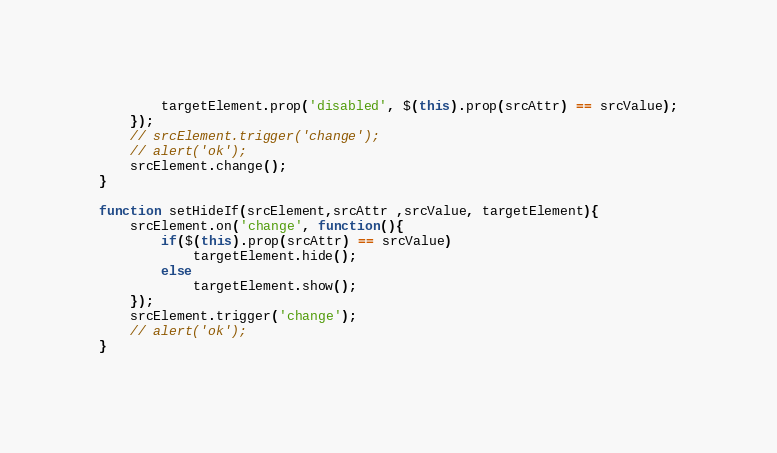<code> <loc_0><loc_0><loc_500><loc_500><_JavaScript_>        targetElement.prop('disabled', $(this).prop(srcAttr) == srcValue);
    });
    // srcElement.trigger('change');
    // alert('ok');
    srcElement.change();
}

function setHideIf(srcElement,srcAttr ,srcValue, targetElement){
    srcElement.on('change', function(){
        if($(this).prop(srcAttr) == srcValue)
            targetElement.hide();
        else
            targetElement.show();
    });
    srcElement.trigger('change');
    // alert('ok');
}</code> 